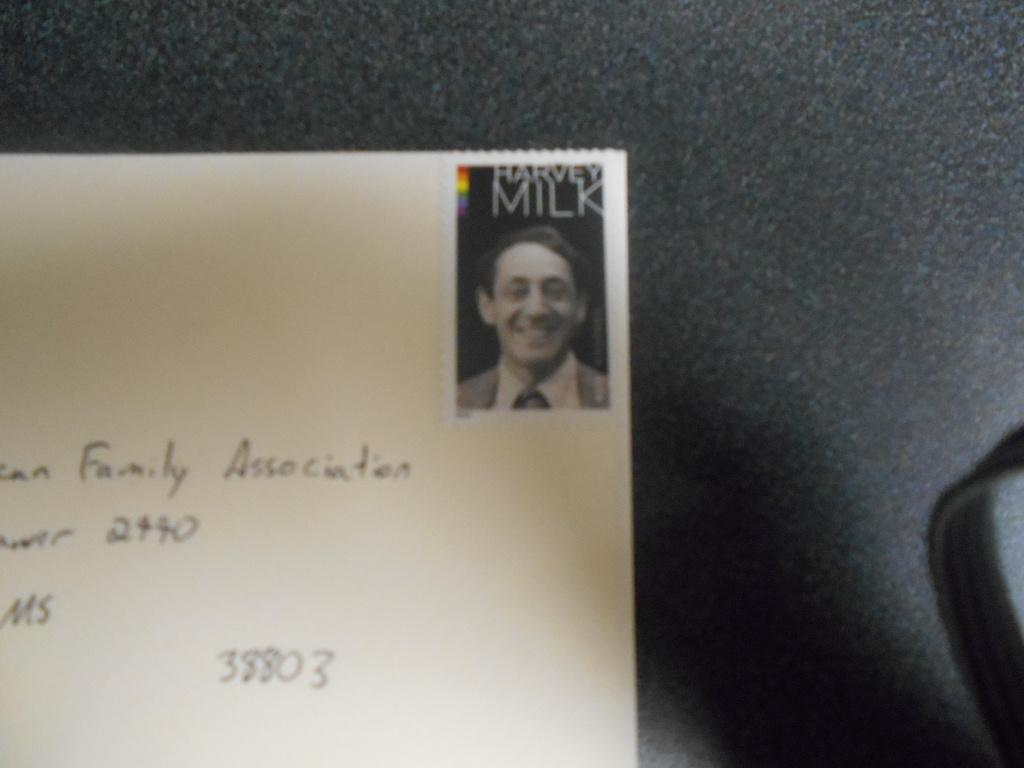What is the main object in the image? There is a card in the image. What is shown on the card? The card has a person depicted on it. Are there any words or letters on the card? Yes, there is text on the card. Where is the card located in the image? The card is placed on a platform. Can you see a monkey playing with a cream-filled balloon in the image? No, there is no monkey or balloon present in the image. The image only features a card with a person depicted on it, text, and a platform. 